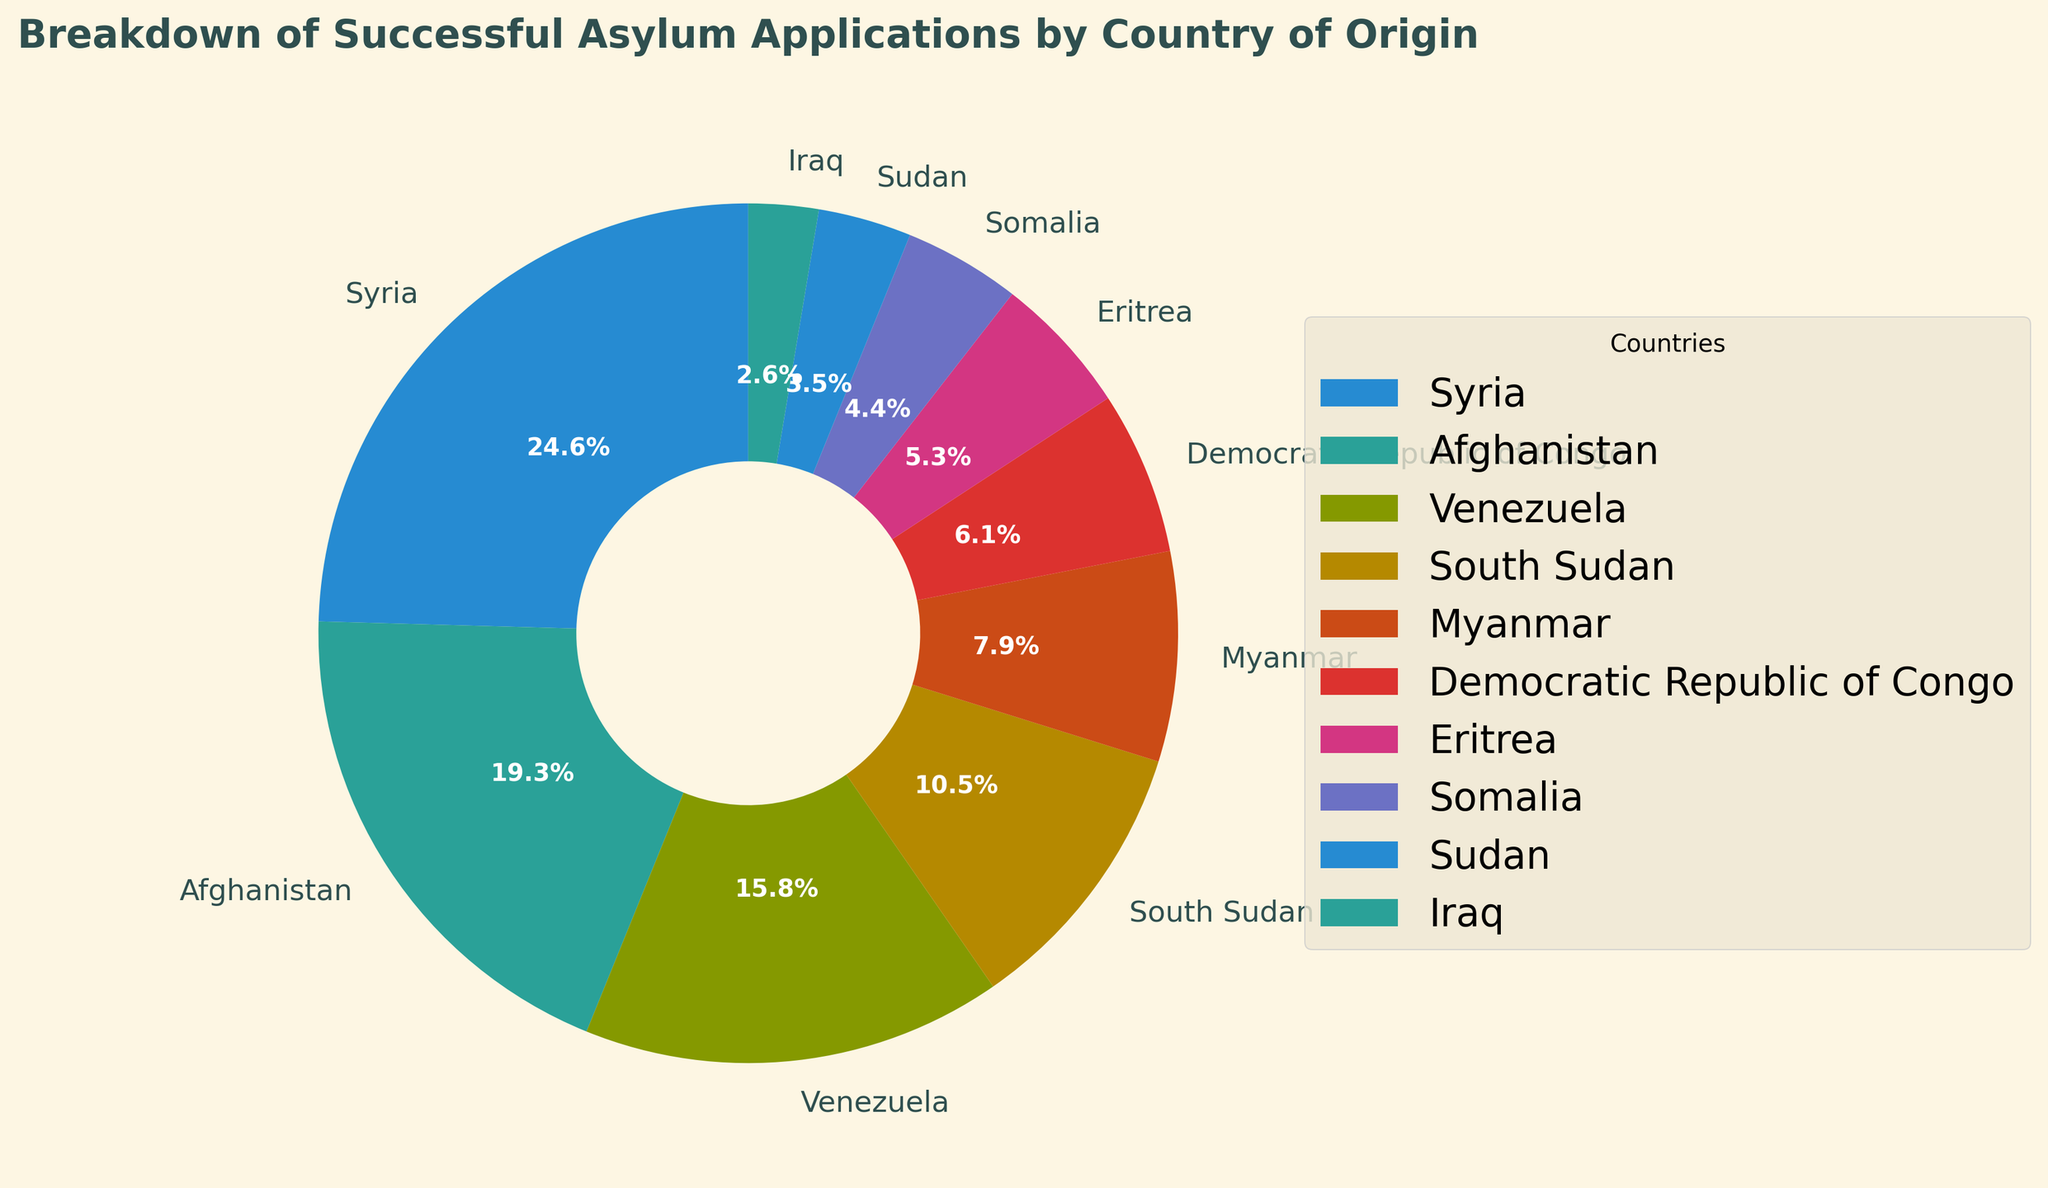what percentage of successful asylum applications come from Syria? Syria's segment on the pie chart shows 28%, which means Syria accounts for 28% of the total successful asylum applications.
Answer: 28% Which country has the least amount of successful asylum applications? By examining the pie chart, it can be seen that Iraq has the smallest segment, indicating the least amount of successful asylum applications.
Answer: Iraq How many successful asylum applications are there from Myanmar and Eritrea combined? Adding the numbers from the pie chart, Myanmar has 9 applications and Eritrea has 6 applications. 9 + 6 = 15
Answer: 15 What is the difference in successful asylum applications between Afghanistan and Somalia? The chart shows Afghanistan with 22 applications and Somalia with 5 applications. Subtracting these, 22 - 5 = 17
Answer: 17 Which country contributes more to successful asylum applications, South Sudan or Venezuela? Referring to the pie chart, Venezuela has 18 applications and South Sudan has 12 applications. Comparatively, Venezuela contributes more.
Answer: Venezuela What is the percentage of successful asylum applications coming from South Sudan and Syria combined? South Sudan contributes 12 applications and Syria contributes 28 applications. Summing these, 12 + 28 = 40 applications. The total number of applications is 114, so the combined percentage is (40 / 114) * 100 = 35.1%
Answer: 35.1% What is the visual attribute difference between the segment representing Syria and Iraq? The pie chart's segment for Syria is much larger than that for Iraq, indicating a significantly larger number of successful asylum applications from Syria as compared to Iraq.
Answer: Syria's segment is larger How many more successful asylum applications are there from Venezuela compared to Iraq? According to the pie chart, Venezuela has 18 applications and Iraq has 3 applications. Thus, there are 18 - 3 = 15 more applications from Venezuela.
Answer: 15 